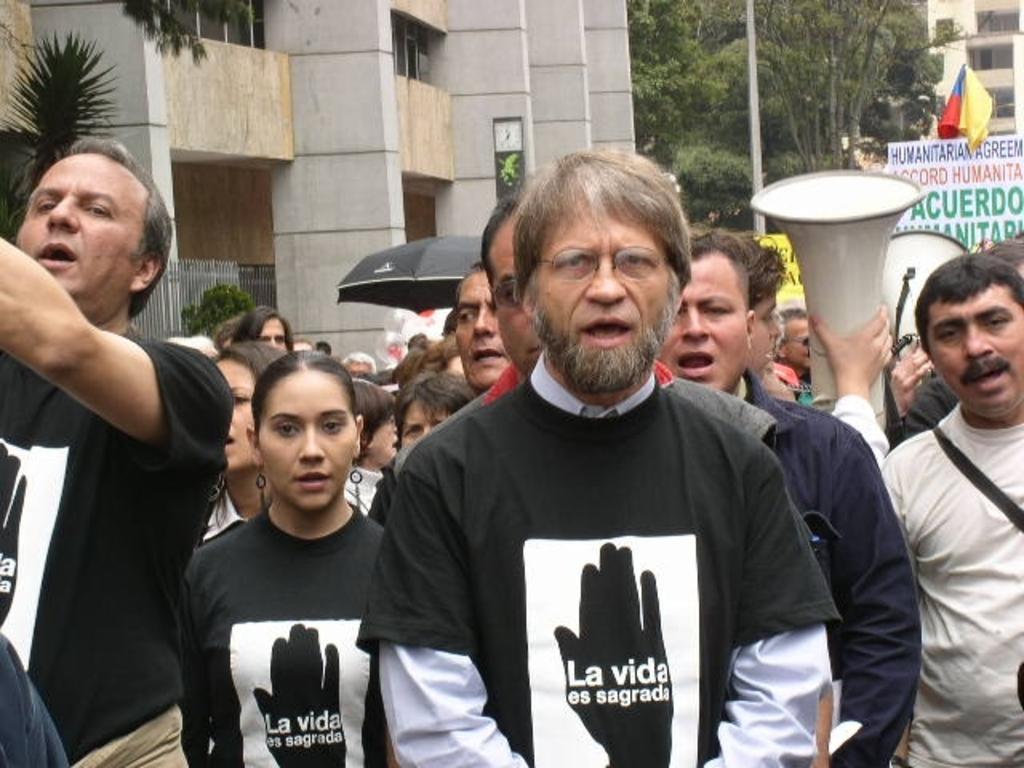Describe this image in one or two sentences. In this image we can see the people standing. In the background we can see the building, flag, umbrella, speakers and also a board with text. Image also consists of trees. 